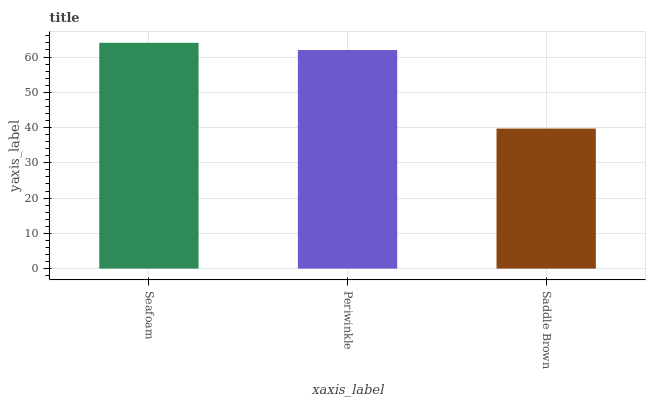Is Periwinkle the minimum?
Answer yes or no. No. Is Periwinkle the maximum?
Answer yes or no. No. Is Seafoam greater than Periwinkle?
Answer yes or no. Yes. Is Periwinkle less than Seafoam?
Answer yes or no. Yes. Is Periwinkle greater than Seafoam?
Answer yes or no. No. Is Seafoam less than Periwinkle?
Answer yes or no. No. Is Periwinkle the high median?
Answer yes or no. Yes. Is Periwinkle the low median?
Answer yes or no. Yes. Is Seafoam the high median?
Answer yes or no. No. Is Saddle Brown the low median?
Answer yes or no. No. 